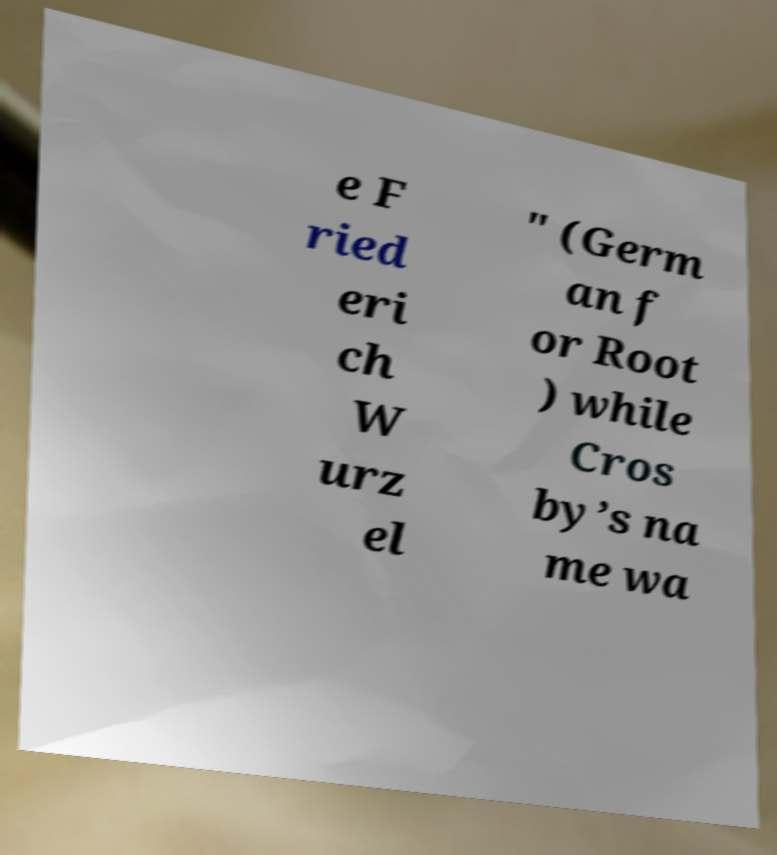For documentation purposes, I need the text within this image transcribed. Could you provide that? e F ried eri ch W urz el " (Germ an f or Root ) while Cros by’s na me wa 